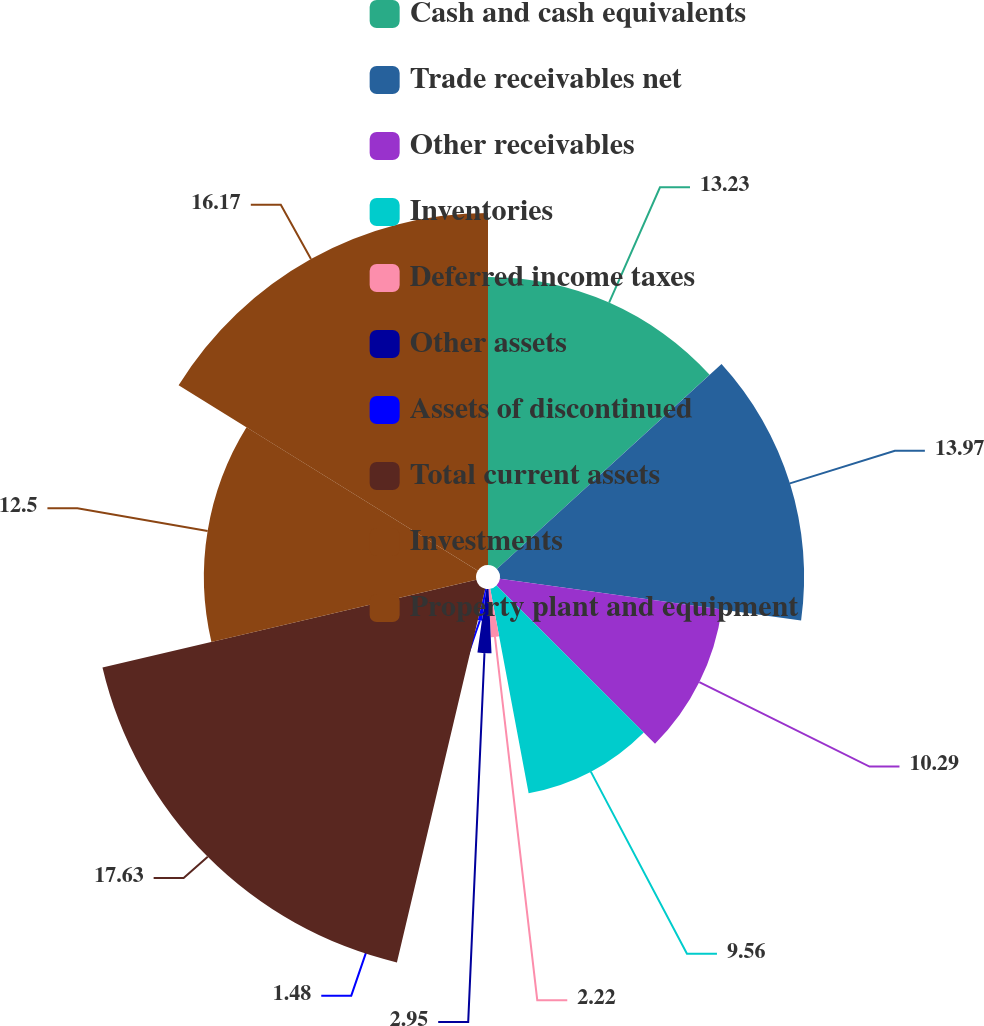Convert chart. <chart><loc_0><loc_0><loc_500><loc_500><pie_chart><fcel>Cash and cash equivalents<fcel>Trade receivables net<fcel>Other receivables<fcel>Inventories<fcel>Deferred income taxes<fcel>Other assets<fcel>Assets of discontinued<fcel>Total current assets<fcel>Investments<fcel>Property plant and equipment<nl><fcel>13.23%<fcel>13.97%<fcel>10.29%<fcel>9.56%<fcel>2.22%<fcel>2.95%<fcel>1.48%<fcel>17.64%<fcel>12.5%<fcel>16.17%<nl></chart> 